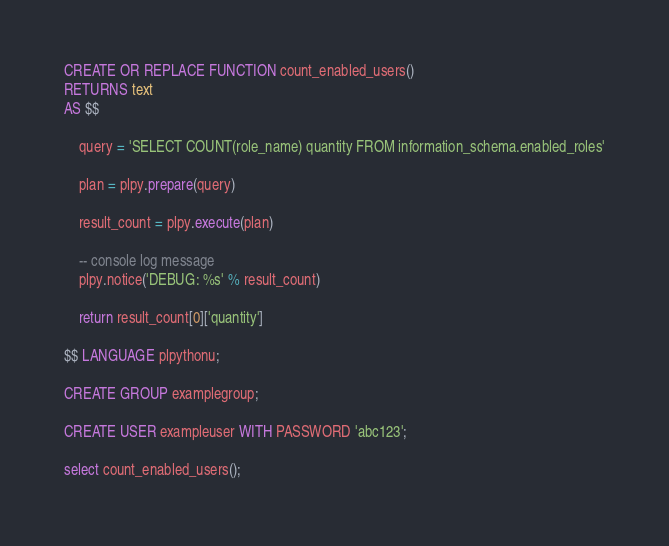<code> <loc_0><loc_0><loc_500><loc_500><_SQL_>CREATE OR REPLACE FUNCTION count_enabled_users()
RETURNS text
AS $$

	query = 'SELECT COUNT(role_name) quantity FROM information_schema.enabled_roles'

	plan = plpy.prepare(query)

	result_count = plpy.execute(plan)

    -- console log message
	plpy.notice('DEBUG: %s' % result_count)

	return result_count[0]['quantity']

$$ LANGUAGE plpythonu;

CREATE GROUP examplegroup;

CREATE USER exampleuser WITH PASSWORD 'abc123';

select count_enabled_users();
</code> 